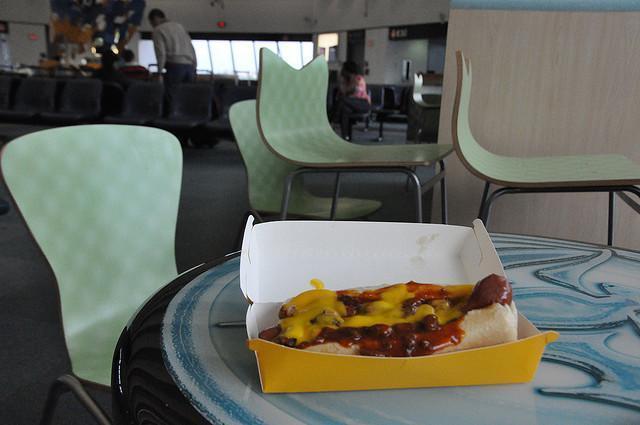How many hot dogs are there?
Give a very brief answer. 1. How many chairs are visible?
Give a very brief answer. 6. 